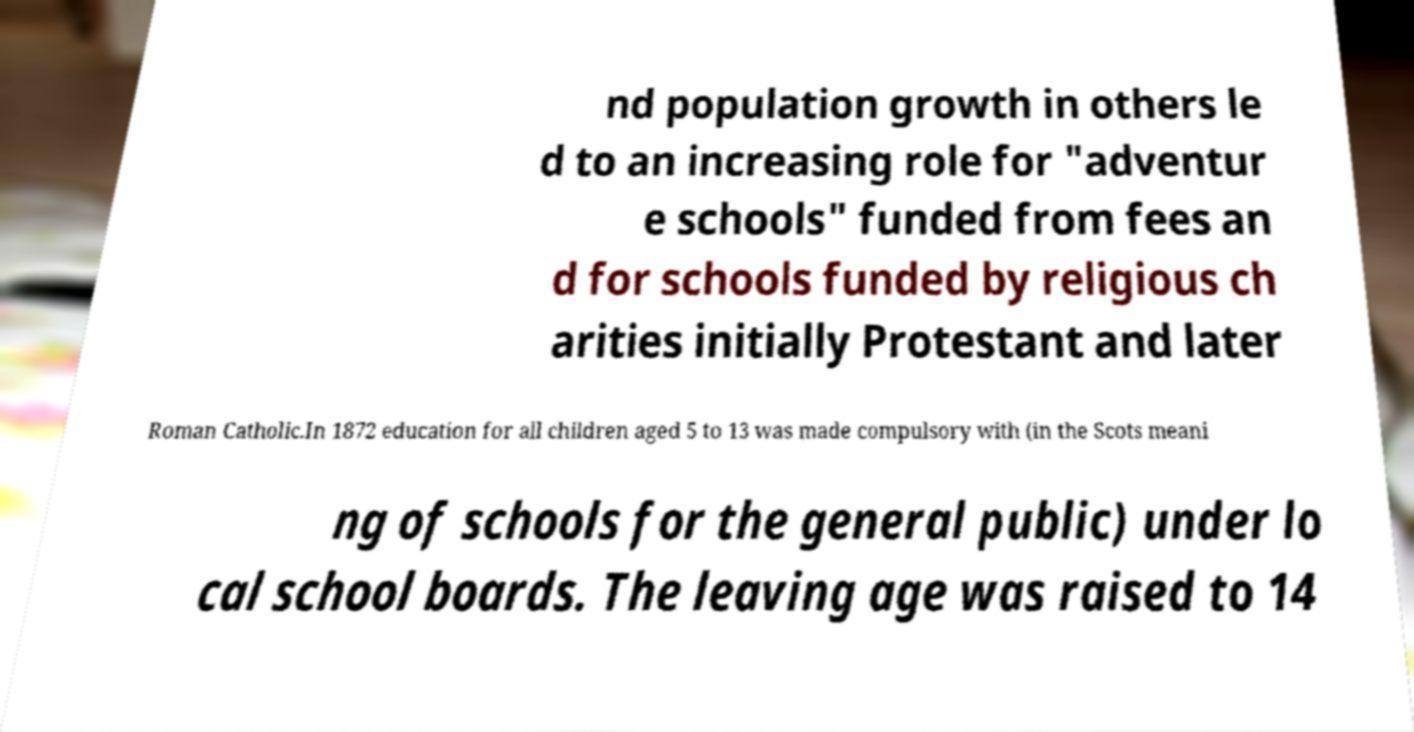Please read and relay the text visible in this image. What does it say? nd population growth in others le d to an increasing role for "adventur e schools" funded from fees an d for schools funded by religious ch arities initially Protestant and later Roman Catholic.In 1872 education for all children aged 5 to 13 was made compulsory with (in the Scots meani ng of schools for the general public) under lo cal school boards. The leaving age was raised to 14 